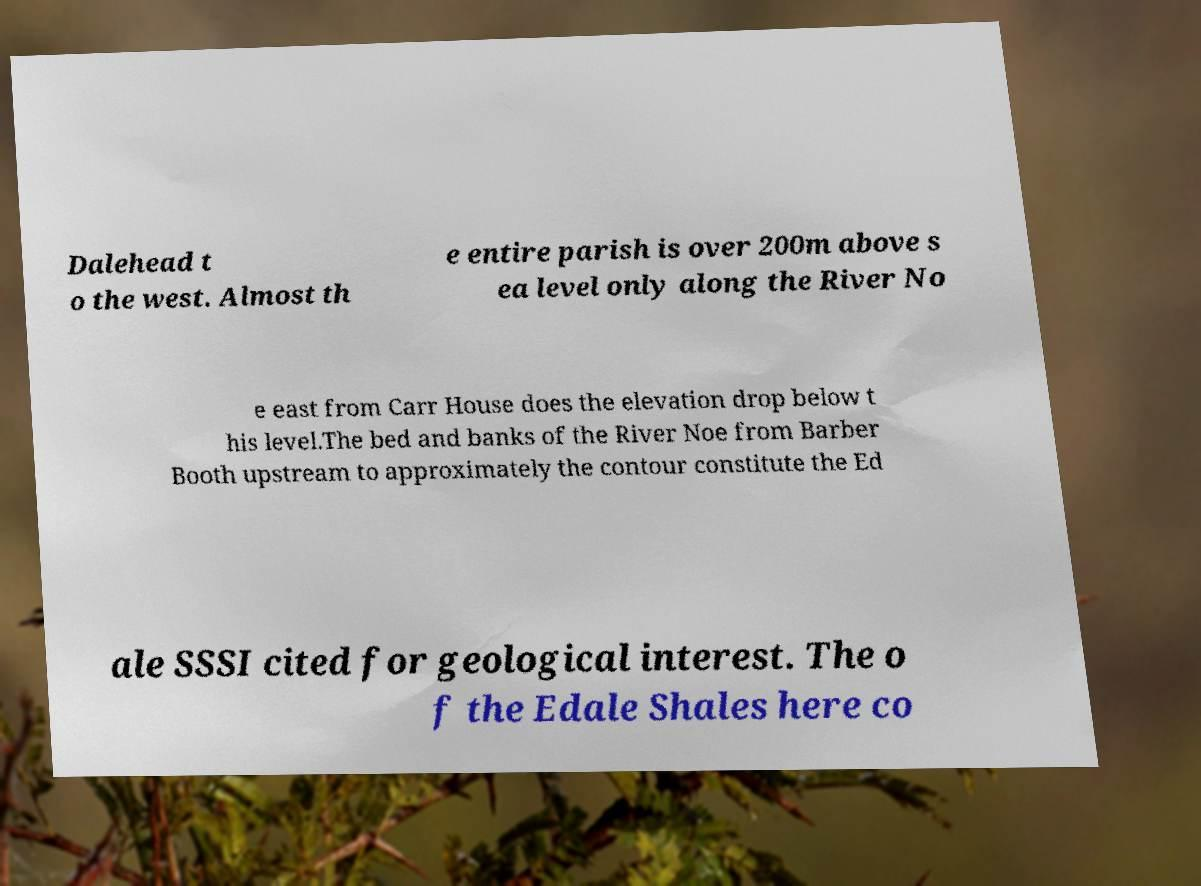For documentation purposes, I need the text within this image transcribed. Could you provide that? Dalehead t o the west. Almost th e entire parish is over 200m above s ea level only along the River No e east from Carr House does the elevation drop below t his level.The bed and banks of the River Noe from Barber Booth upstream to approximately the contour constitute the Ed ale SSSI cited for geological interest. The o f the Edale Shales here co 